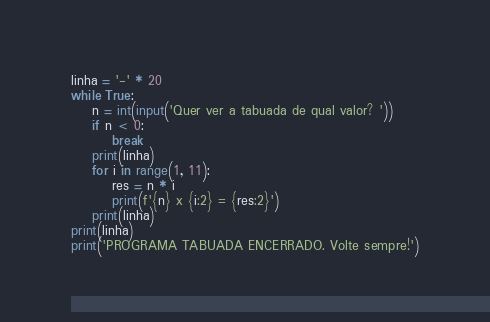<code> <loc_0><loc_0><loc_500><loc_500><_Python_>linha = '-' * 20
while True:
    n = int(input('Quer ver a tabuada de qual valor? '))
    if n < 0:
        break
    print(linha)
    for i in range(1, 11):
        res = n * i
        print(f'{n} x {i:2} = {res:2}')
    print(linha)
print(linha)
print('PROGRAMA TABUADA ENCERRADO. Volte sempre!')</code> 